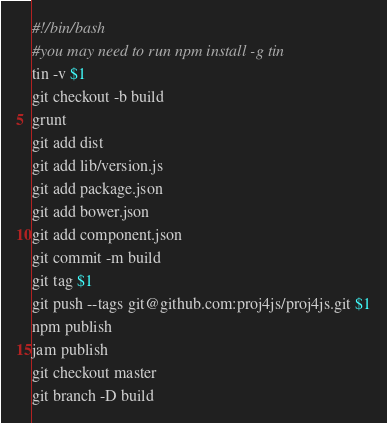Convert code to text. <code><loc_0><loc_0><loc_500><loc_500><_Bash_>#!/bin/bash
#you may need to run npm install -g tin
tin -v $1
git checkout -b build
grunt
git add dist
git add lib/version.js
git add package.json
git add bower.json
git add component.json
git commit -m build
git tag $1
git push --tags git@github.com:proj4js/proj4js.git $1
npm publish
jam publish
git checkout master
git branch -D build</code> 